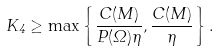Convert formula to latex. <formula><loc_0><loc_0><loc_500><loc_500>K _ { 4 } \geq \max \left \{ \frac { C ( M ) } { P ( \Omega ) \eta } , \frac { C ( M ) } { \eta } \right \} .</formula> 